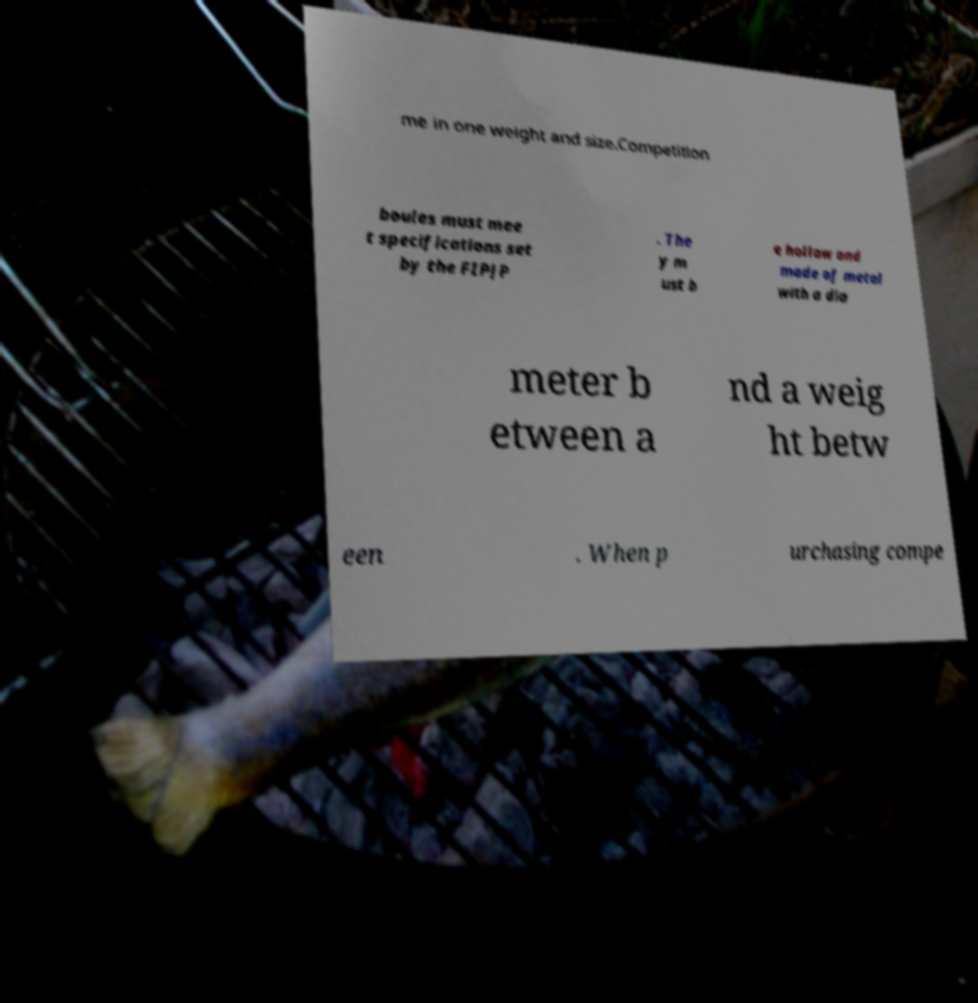Can you accurately transcribe the text from the provided image for me? me in one weight and size.Competition boules must mee t specifications set by the FIPJP . The y m ust b e hollow and made of metal with a dia meter b etween a nd a weig ht betw een . When p urchasing compe 